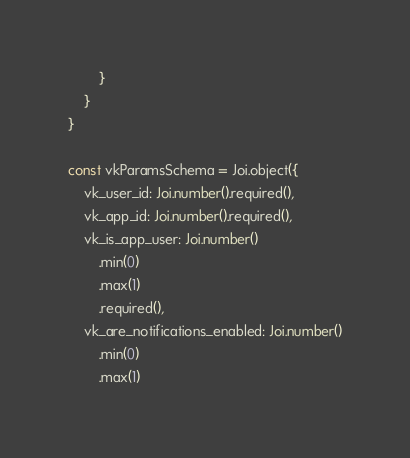Convert code to text. <code><loc_0><loc_0><loc_500><loc_500><_TypeScript_>        }
    }
}

const vkParamsSchema = Joi.object({
    vk_user_id: Joi.number().required(),
    vk_app_id: Joi.number().required(),
    vk_is_app_user: Joi.number()
        .min(0)
        .max(1)
        .required(),
    vk_are_notifications_enabled: Joi.number()
        .min(0)
        .max(1)</code> 